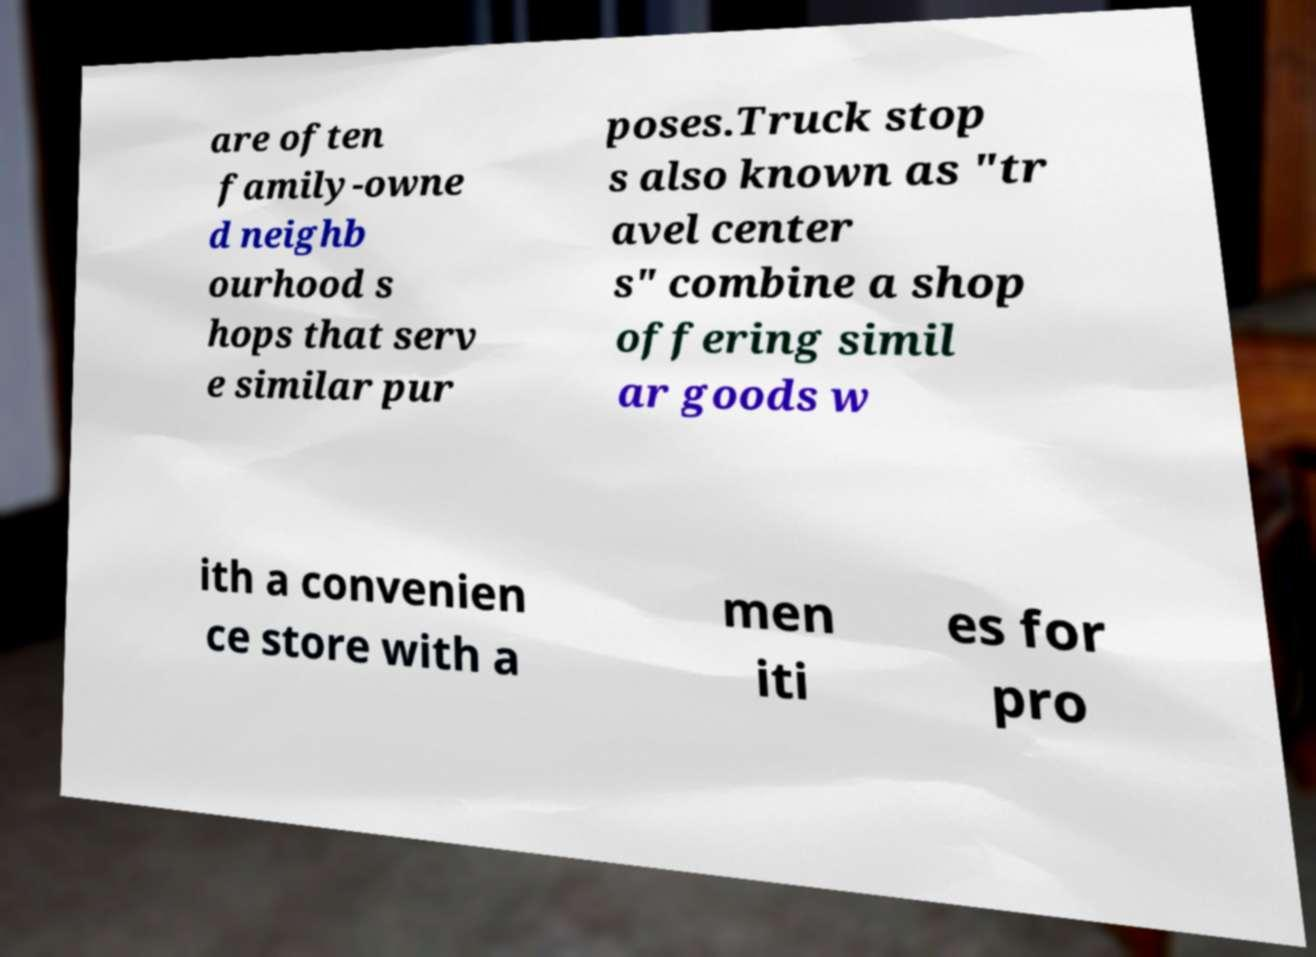There's text embedded in this image that I need extracted. Can you transcribe it verbatim? are often family-owne d neighb ourhood s hops that serv e similar pur poses.Truck stop s also known as "tr avel center s" combine a shop offering simil ar goods w ith a convenien ce store with a men iti es for pro 